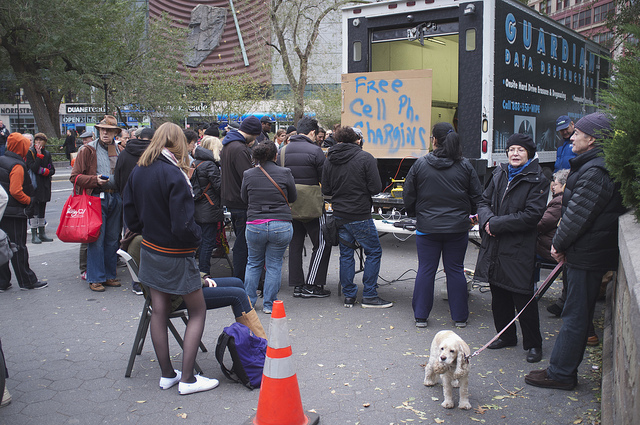Please transcribe the text information in this image. FREE cell Ph. GUARDIAN DATA Shargins 